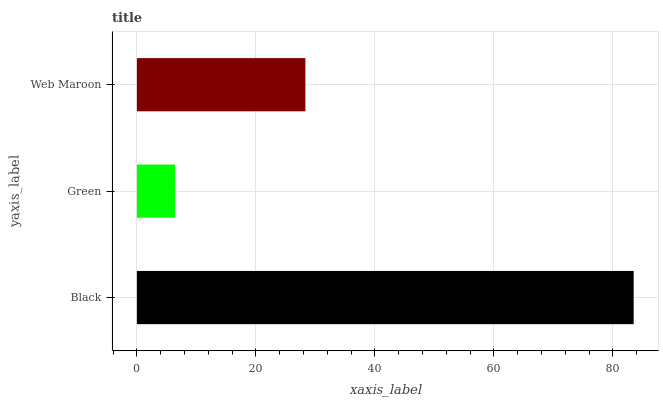Is Green the minimum?
Answer yes or no. Yes. Is Black the maximum?
Answer yes or no. Yes. Is Web Maroon the minimum?
Answer yes or no. No. Is Web Maroon the maximum?
Answer yes or no. No. Is Web Maroon greater than Green?
Answer yes or no. Yes. Is Green less than Web Maroon?
Answer yes or no. Yes. Is Green greater than Web Maroon?
Answer yes or no. No. Is Web Maroon less than Green?
Answer yes or no. No. Is Web Maroon the high median?
Answer yes or no. Yes. Is Web Maroon the low median?
Answer yes or no. Yes. Is Black the high median?
Answer yes or no. No. Is Black the low median?
Answer yes or no. No. 